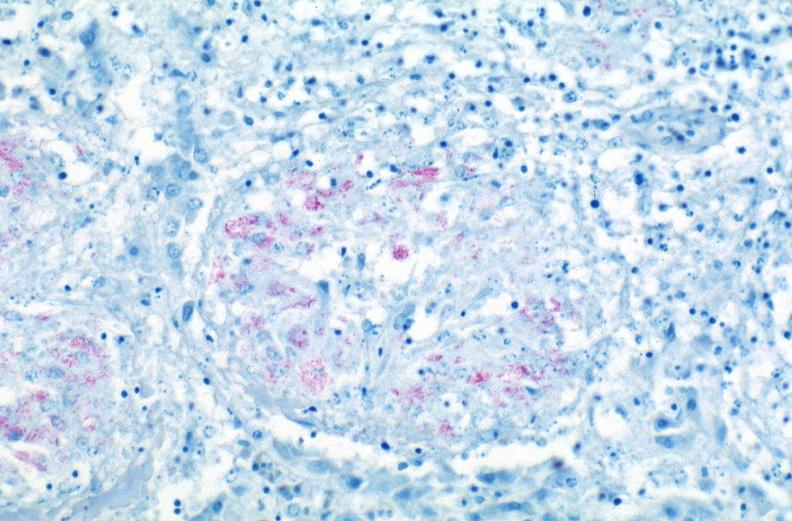what does this image show?
Answer the question using a single word or phrase. Lung 